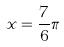Convert formula to latex. <formula><loc_0><loc_0><loc_500><loc_500>x = \frac { 7 } { 6 } \pi</formula> 